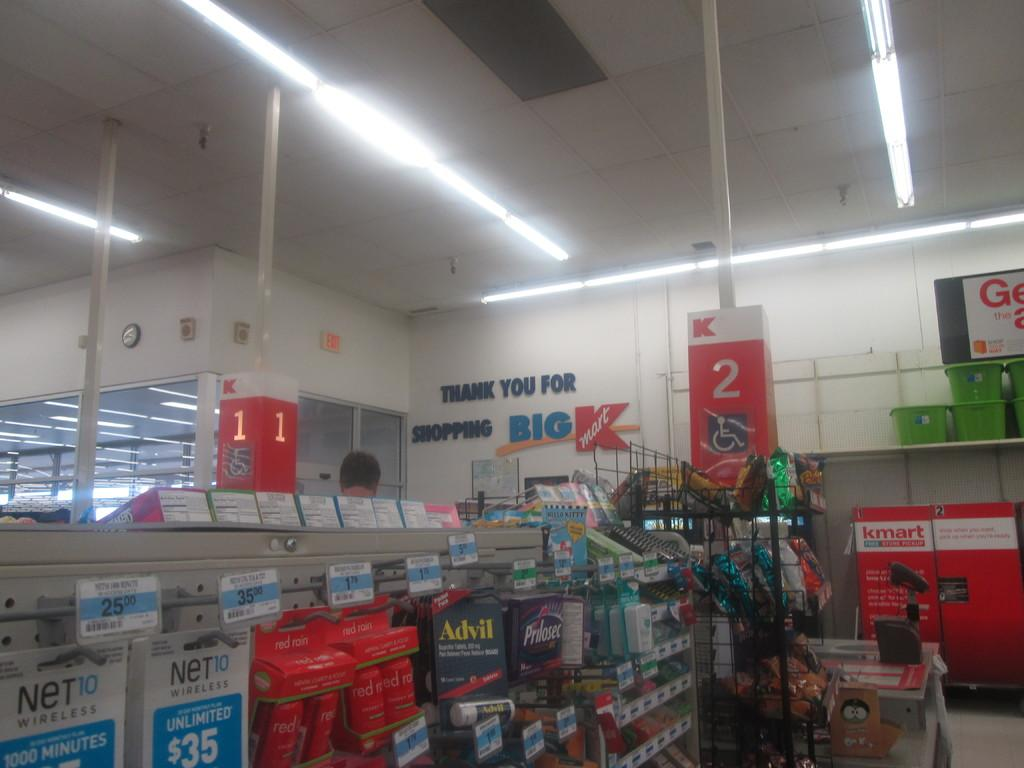<image>
Give a short and clear explanation of the subsequent image. An aisle containing Advil and Prilosec is in the store K-Mart. 